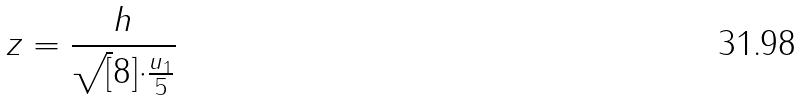Convert formula to latex. <formula><loc_0><loc_0><loc_500><loc_500>z = \frac { h } { \sqrt { [ } 8 ] { \cdot \frac { u _ { 1 } } { 5 } } }</formula> 